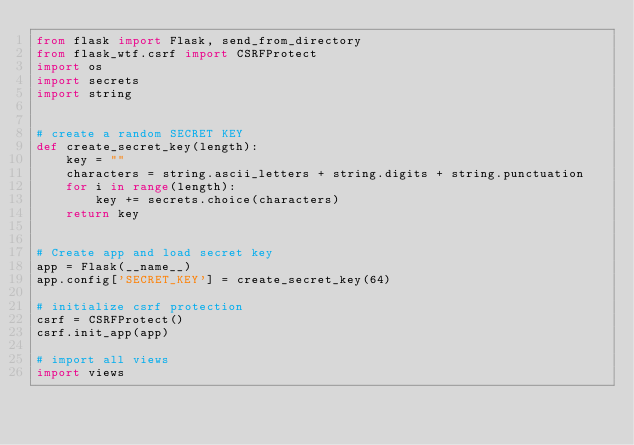<code> <loc_0><loc_0><loc_500><loc_500><_Python_>from flask import Flask, send_from_directory
from flask_wtf.csrf import CSRFProtect
import os
import secrets
import string


# create a random SECRET KEY
def create_secret_key(length):
    key = ""
    characters = string.ascii_letters + string.digits + string.punctuation
    for i in range(length):
        key += secrets.choice(characters)
    return key


# Create app and load secret key
app = Flask(__name__)
app.config['SECRET_KEY'] = create_secret_key(64)

# initialize csrf protection
csrf = CSRFProtect()
csrf.init_app(app)

# import all views
import views
</code> 